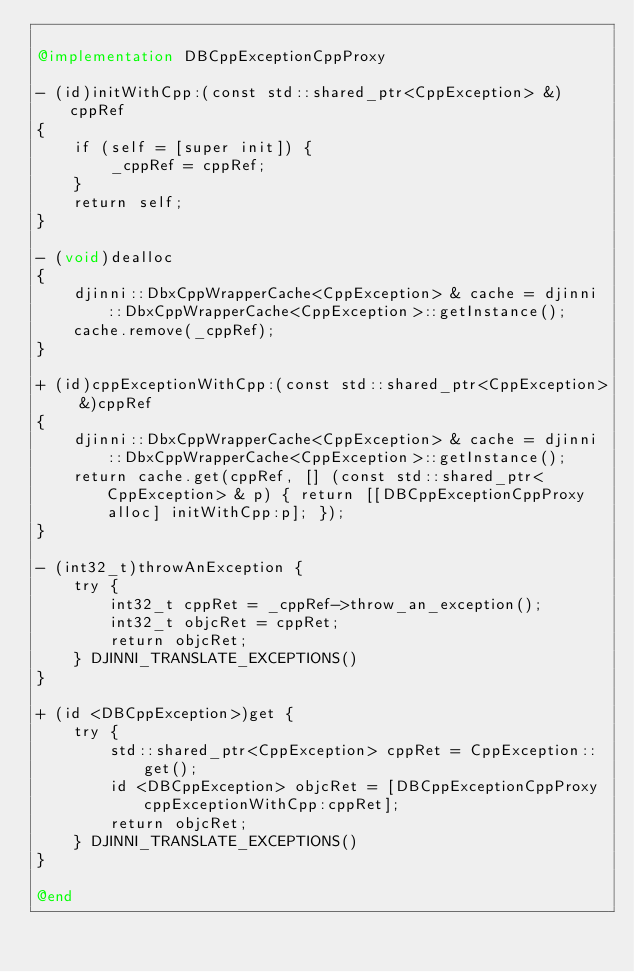<code> <loc_0><loc_0><loc_500><loc_500><_ObjectiveC_>
@implementation DBCppExceptionCppProxy

- (id)initWithCpp:(const std::shared_ptr<CppException> &)cppRef
{
    if (self = [super init]) {
        _cppRef = cppRef;
    }
    return self;
}

- (void)dealloc
{
    djinni::DbxCppWrapperCache<CppException> & cache = djinni::DbxCppWrapperCache<CppException>::getInstance();
    cache.remove(_cppRef);
}

+ (id)cppExceptionWithCpp:(const std::shared_ptr<CppException> &)cppRef
{
    djinni::DbxCppWrapperCache<CppException> & cache = djinni::DbxCppWrapperCache<CppException>::getInstance();
    return cache.get(cppRef, [] (const std::shared_ptr<CppException> & p) { return [[DBCppExceptionCppProxy alloc] initWithCpp:p]; });
}

- (int32_t)throwAnException {
    try {
        int32_t cppRet = _cppRef->throw_an_exception();
        int32_t objcRet = cppRet;
        return objcRet;
    } DJINNI_TRANSLATE_EXCEPTIONS()
}

+ (id <DBCppException>)get {
    try {
        std::shared_ptr<CppException> cppRet = CppException::get();
        id <DBCppException> objcRet = [DBCppExceptionCppProxy cppExceptionWithCpp:cppRet];
        return objcRet;
    } DJINNI_TRANSLATE_EXCEPTIONS()
}

@end
</code> 